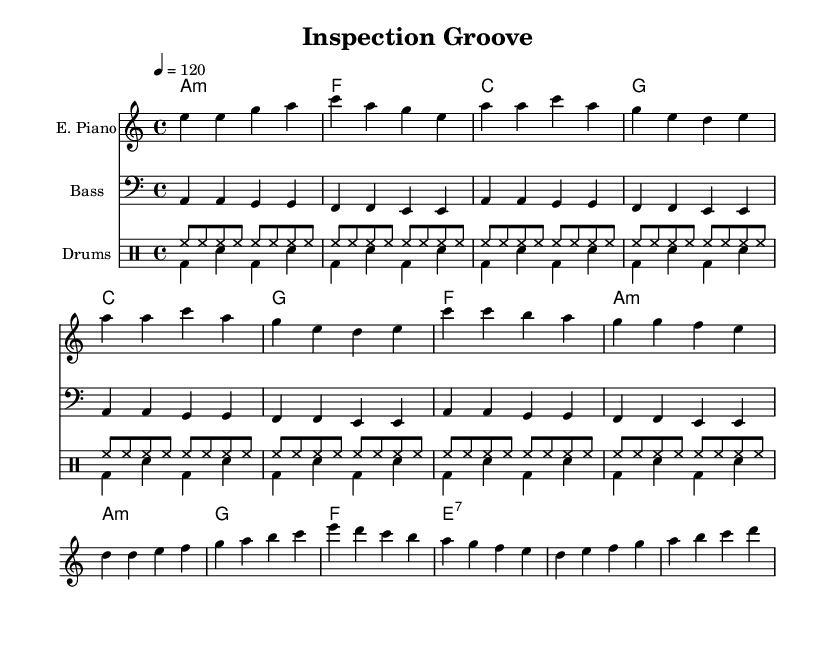What is the key signature of this music? The key signature is indicated by the presence of the note "A" and "C" without any sharps or flats in the key signature box at the beginning of the staff. Therefore, it represents A minor.
Answer: A minor What is the time signature of this music? The time signature is indicated by the fraction at the beginning of the sheet music, which displays "4/4". It means there are four beats in a measure and the quarter note gets one beat.
Answer: 4/4 What is the tempo marking for this piece? The tempo marking is provided at the beginning and is expressed as "4 = 120", indicating that there are 120 beats per minute with a quarter note counting as one beat.
Answer: 120 How many sections are there in this music piece? The structure consists of four sections: Intro, Verse, Chorus, and Bridge. Each section has a distinct musical pattern that contributes to the overall composition.
Answer: Four What is the primary instrument used for the melody in this sheet music? The primary instrument is indicated as "E. Piano" in the staff heading, which shows that the electric piano carries the melodic part of the composition.
Answer: E. Piano Which chord appears in both the Verse and Chorus sections? The chord "A minor" appears in the Verse and also returns in the Chorus of the music sheet, indicating its significance in the harmonic structure across sections.
Answer: A minor What rhythmic pattern is used in the drums for the upbeat? The drums are indicated to play a repetitive eighth-note hi-hat pattern, shown in the "drumsUp" section, which uses the high-hat notation to maintain a consistent groove.
Answer: Hi-hat pattern 